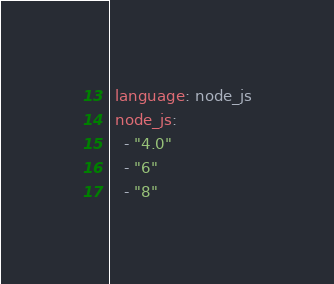<code> <loc_0><loc_0><loc_500><loc_500><_YAML_> language: node_js
 node_js:
   - "4.0"
   - "6"
   - "8"
</code> 